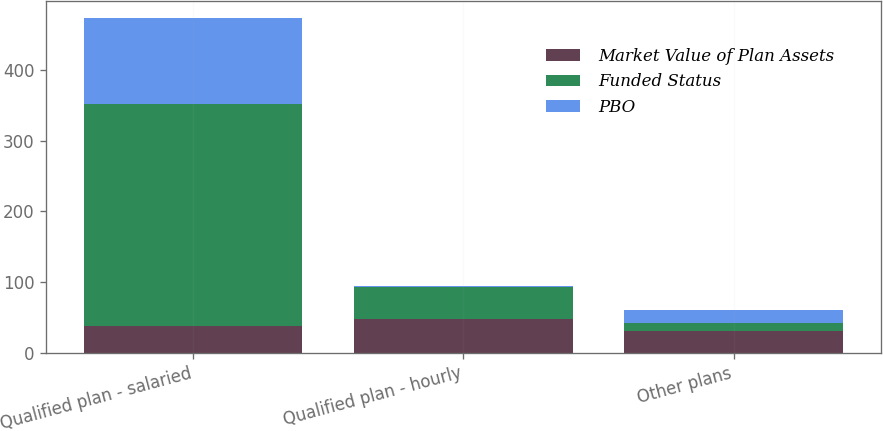Convert chart. <chart><loc_0><loc_0><loc_500><loc_500><stacked_bar_chart><ecel><fcel>Qualified plan - salaried<fcel>Qualified plan - hourly<fcel>Other plans<nl><fcel>Market Value of Plan Assets<fcel>38<fcel>47<fcel>30<nl><fcel>Funded Status<fcel>314<fcel>46<fcel>12<nl><fcel>PBO<fcel>122<fcel>1<fcel>18<nl></chart> 